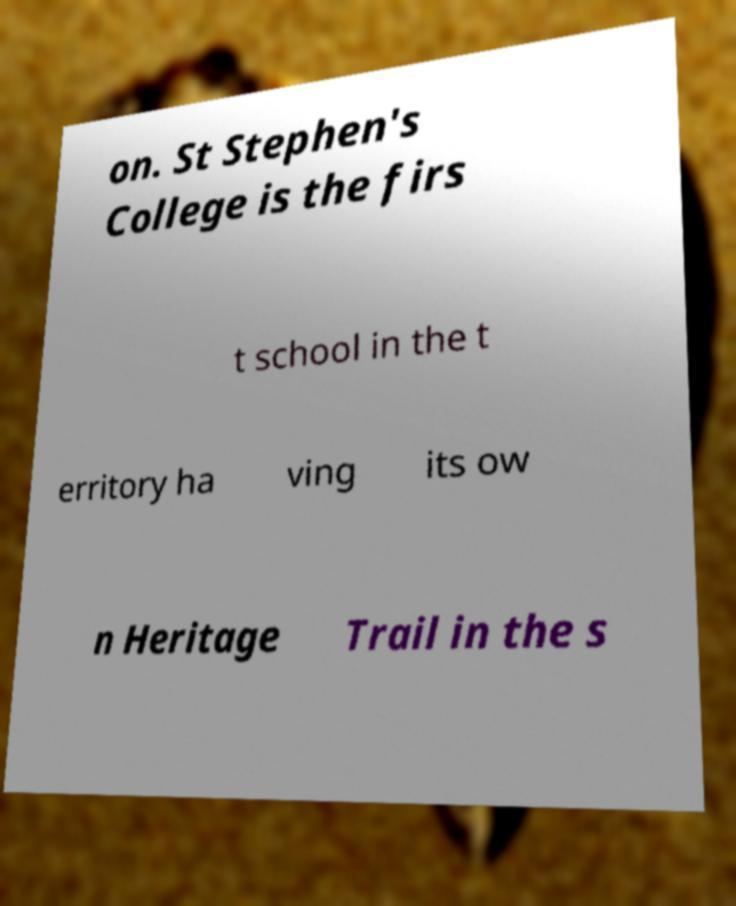Could you assist in decoding the text presented in this image and type it out clearly? on. St Stephen's College is the firs t school in the t erritory ha ving its ow n Heritage Trail in the s 